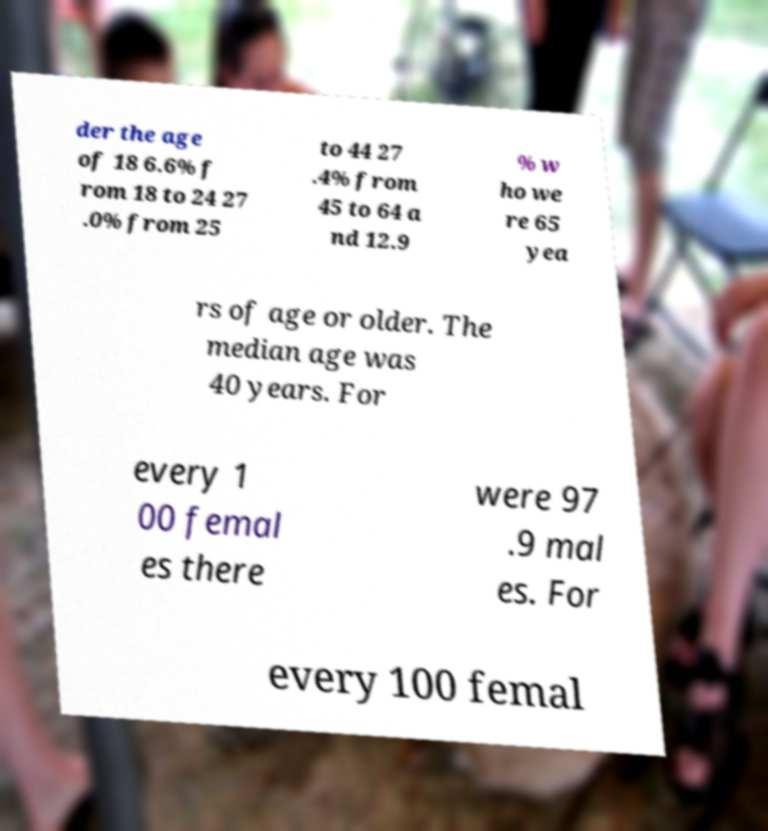Can you accurately transcribe the text from the provided image for me? der the age of 18 6.6% f rom 18 to 24 27 .0% from 25 to 44 27 .4% from 45 to 64 a nd 12.9 % w ho we re 65 yea rs of age or older. The median age was 40 years. For every 1 00 femal es there were 97 .9 mal es. For every 100 femal 